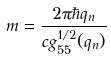<formula> <loc_0><loc_0><loc_500><loc_500>m = \frac { 2 \pi \hbar { q } _ { n } } { c g _ { 5 5 } ^ { 1 / 2 } ( q _ { n } ) }</formula> 